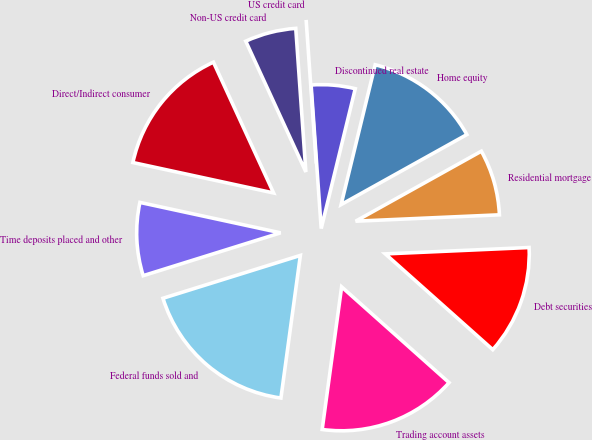Convert chart. <chart><loc_0><loc_0><loc_500><loc_500><pie_chart><fcel>Time deposits placed and other<fcel>Federal funds sold and<fcel>Trading account assets<fcel>Debt securities<fcel>Residential mortgage<fcel>Home equity<fcel>Discontinued real estate<fcel>US credit card<fcel>Non-US credit card<fcel>Direct/Indirect consumer<nl><fcel>8.2%<fcel>18.03%<fcel>15.57%<fcel>12.29%<fcel>7.38%<fcel>13.11%<fcel>4.92%<fcel>0.0%<fcel>5.74%<fcel>14.75%<nl></chart> 